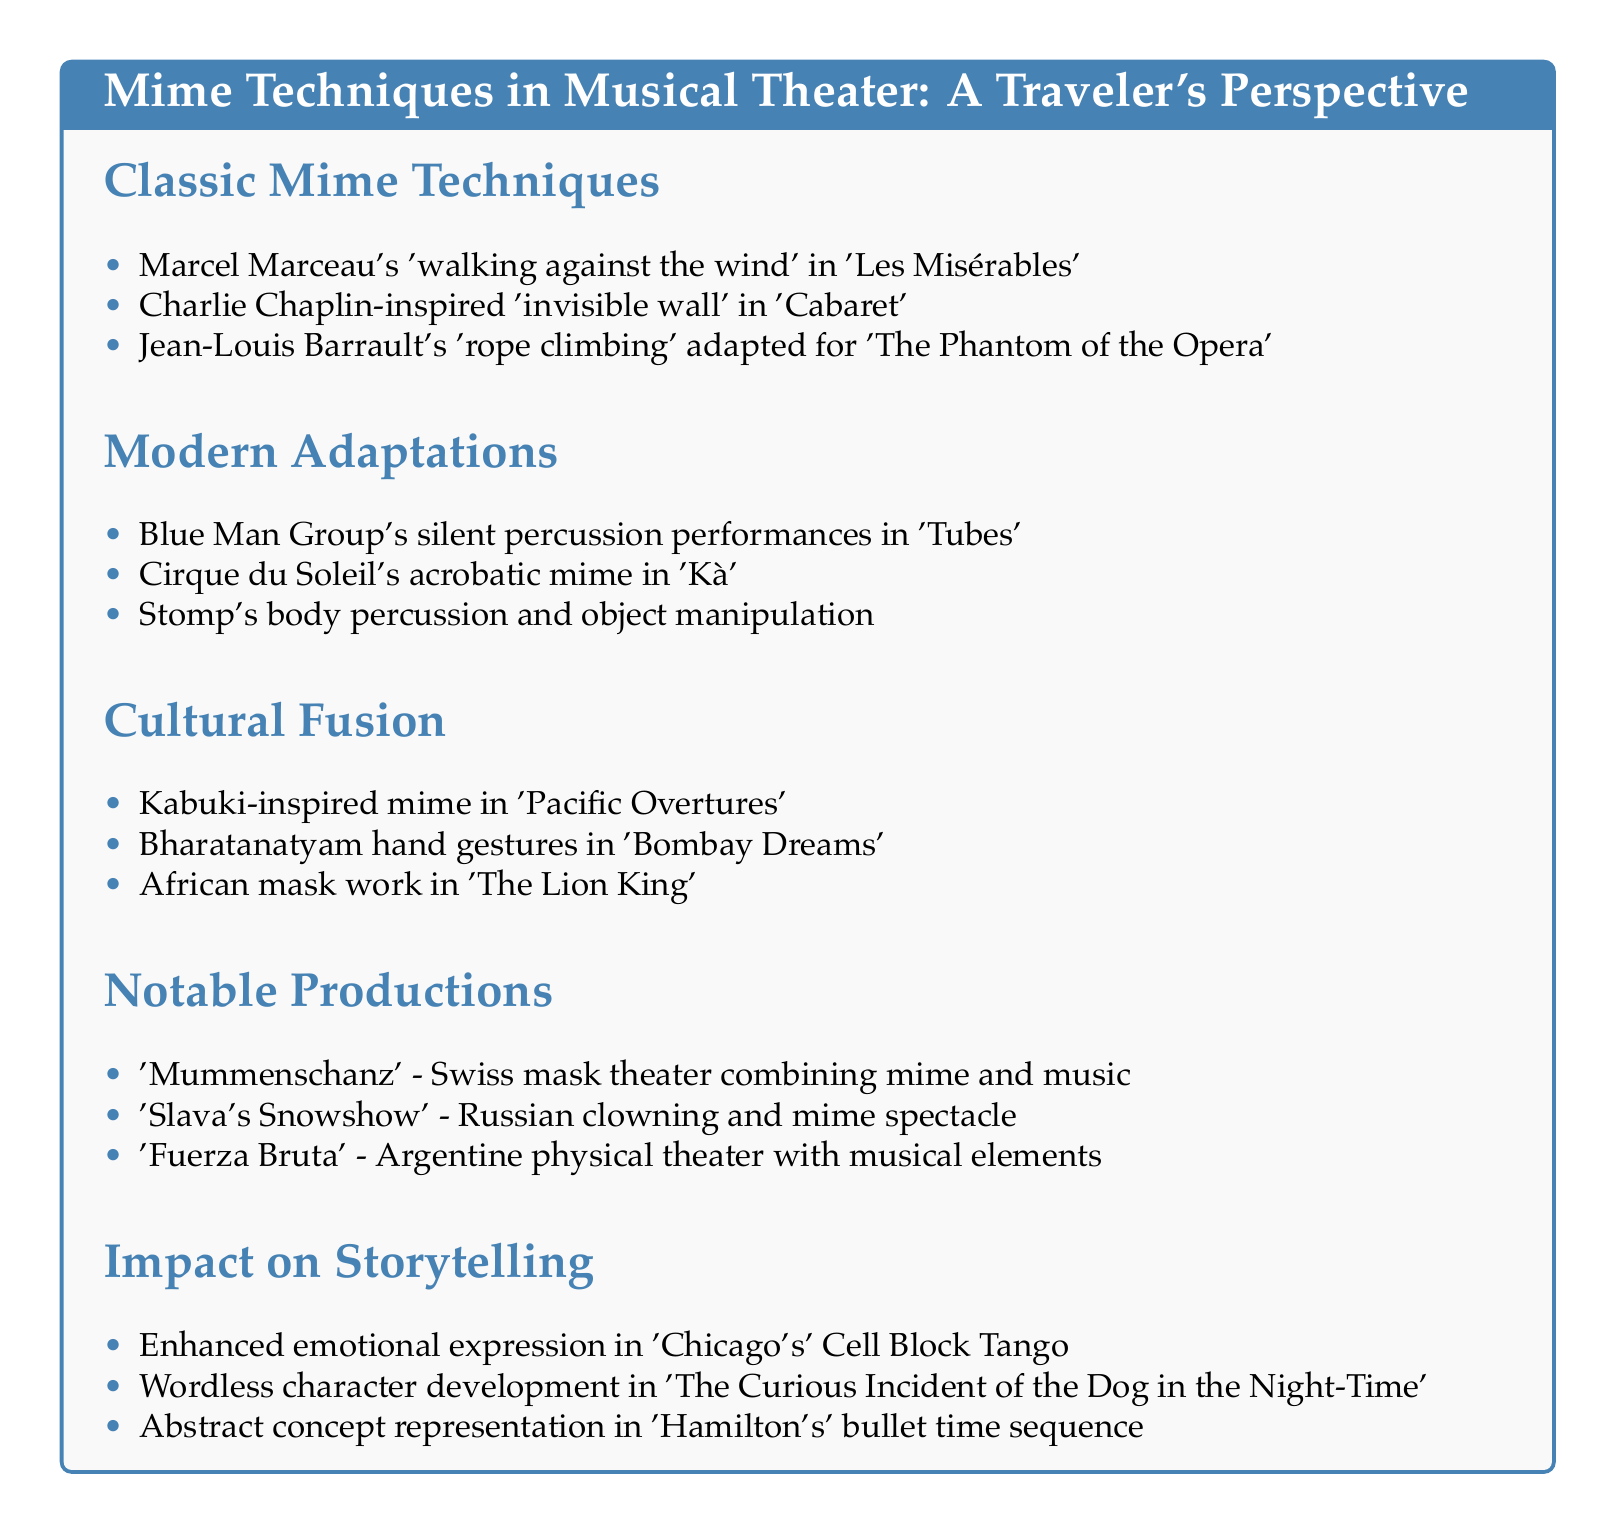What mime technique is used in 'Les Misérables'? The mime technique used in 'Les Misérables' is Marcel Marceau's 'walking against the wind'.
Answer: 'walking against the wind' Which modern group is known for silent percussion in 'Tubes'? The group known for silent percussion in 'Tubes' is the Blue Man Group.
Answer: Blue Man Group What type of mime is used in 'Hamilton's' bullet time sequence? The type of mime used in 'Hamilton's' bullet time sequence is abstract concept representation.
Answer: abstract concept representation How many notable productions are listed in the document? There are three notable productions listed in the document.
Answer: 3 Which theater style combines mime and music in 'Mummenschanz'? The theater style that combines mime and music in 'Mummenschanz' is Swiss mask theater.
Answer: Swiss mask theater What cultural influence is seen in 'Bombay Dreams'? The cultural influence seen in 'Bombay Dreams' is Bharatanatyam hand gestures.
Answer: Bharatanatyam hand gestures Which modern adaptation includes body percussion? The modern adaptation that includes body percussion is Stomp.
Answer: Stomp 